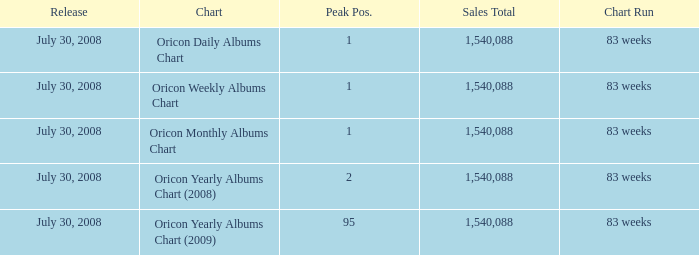Which Sales Total has a Chart of oricon monthly albums chart? 1540088.0. Parse the table in full. {'header': ['Release', 'Chart', 'Peak Pos.', 'Sales Total', 'Chart Run'], 'rows': [['July 30, 2008', 'Oricon Daily Albums Chart', '1', '1,540,088', '83 weeks'], ['July 30, 2008', 'Oricon Weekly Albums Chart', '1', '1,540,088', '83 weeks'], ['July 30, 2008', 'Oricon Monthly Albums Chart', '1', '1,540,088', '83 weeks'], ['July 30, 2008', 'Oricon Yearly Albums Chart (2008)', '2', '1,540,088', '83 weeks'], ['July 30, 2008', 'Oricon Yearly Albums Chart (2009)', '95', '1,540,088', '83 weeks']]} 